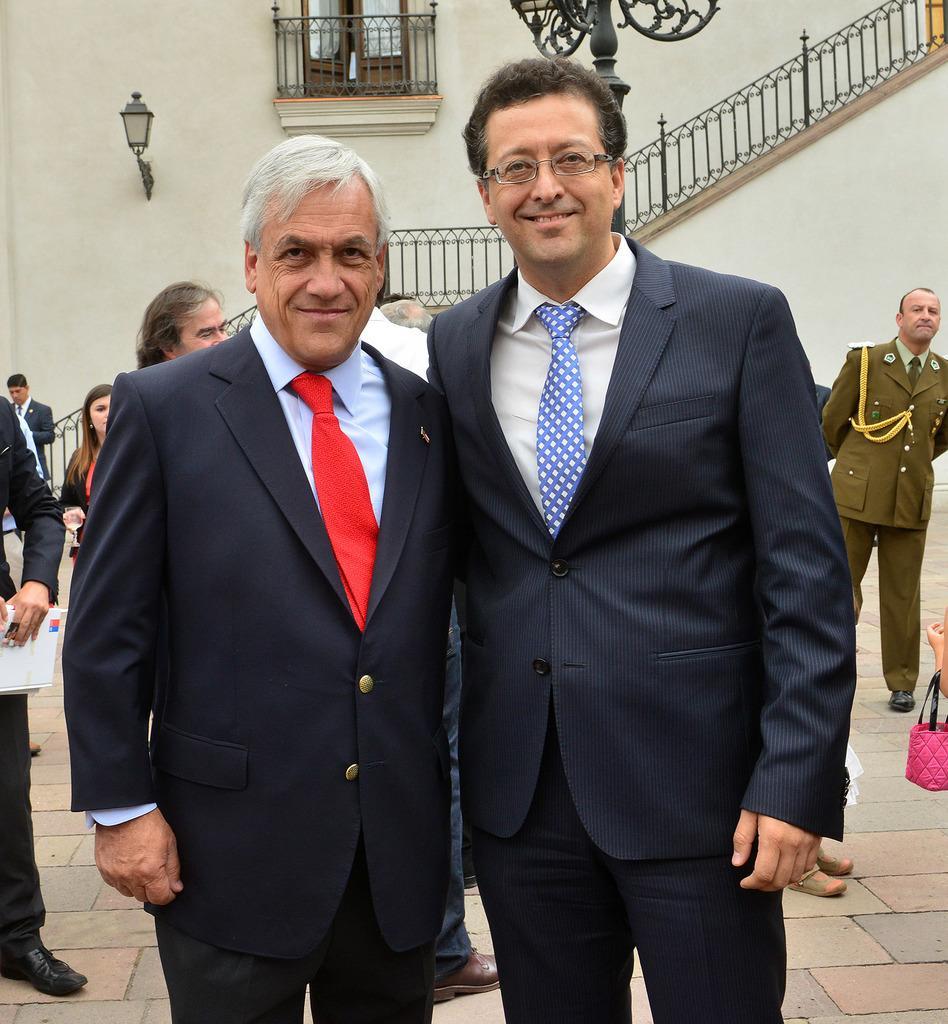How would you summarize this image in a sentence or two? In this image there are two persons standing and smiling, and in the background there are group of people standing, light, iron rods, window of a building. 